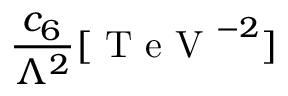<formula> <loc_0><loc_0><loc_500><loc_500>\frac { c _ { 6 } } { \Lambda ^ { 2 } } [ T e V ^ { - 2 } ]</formula> 